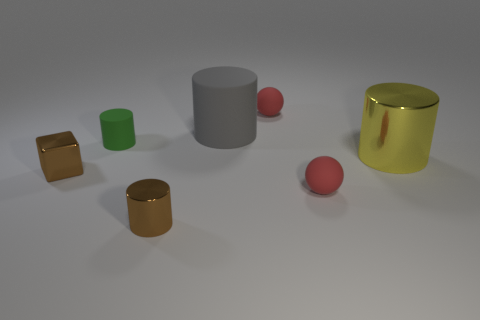Subtract all tiny brown metal cylinders. How many cylinders are left? 3 Subtract all brown cylinders. How many cylinders are left? 3 Subtract 1 blocks. How many blocks are left? 0 Add 1 small cubes. How many objects exist? 8 Subtract all cylinders. How many objects are left? 3 Subtract 0 cyan balls. How many objects are left? 7 Subtract all yellow cylinders. Subtract all cyan blocks. How many cylinders are left? 3 Subtract all red cubes. How many brown cylinders are left? 1 Subtract all cyan matte objects. Subtract all metallic things. How many objects are left? 4 Add 3 large cylinders. How many large cylinders are left? 5 